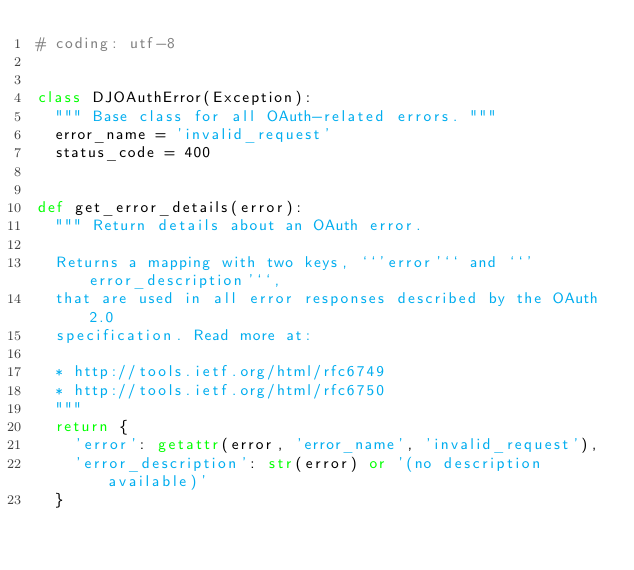<code> <loc_0><loc_0><loc_500><loc_500><_Python_># coding: utf-8


class DJOAuthError(Exception):
  """ Base class for all OAuth-related errors. """
  error_name = 'invalid_request'
  status_code = 400


def get_error_details(error):
  """ Return details about an OAuth error.

  Returns a mapping with two keys, ``'error'`` and ``'error_description'``,
  that are used in all error responses described by the OAuth 2.0
  specification. Read more at:

  * http://tools.ietf.org/html/rfc6749
  * http://tools.ietf.org/html/rfc6750
  """
  return {
    'error': getattr(error, 'error_name', 'invalid_request'),
    'error_description': str(error) or '(no description available)'
  }


</code> 